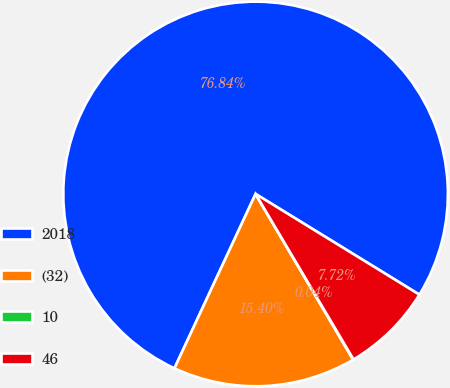Convert chart to OTSL. <chart><loc_0><loc_0><loc_500><loc_500><pie_chart><fcel>2018<fcel>(32)<fcel>10<fcel>46<nl><fcel>76.84%<fcel>15.4%<fcel>0.04%<fcel>7.72%<nl></chart> 